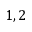Convert formula to latex. <formula><loc_0><loc_0><loc_500><loc_500>1 , 2</formula> 